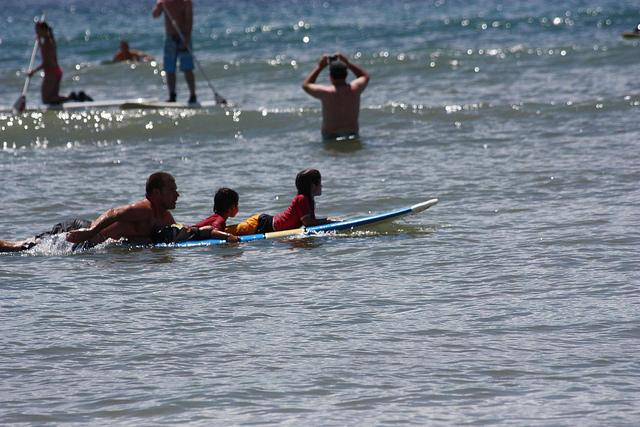What do the persons on boards here wish for? Please explain your reasoning. big waves. Surfers are always looking for waves. 